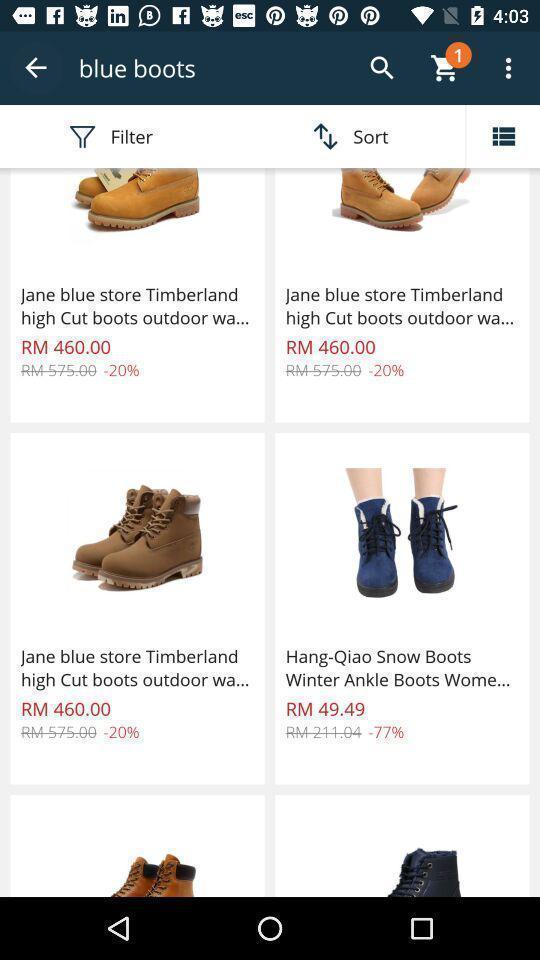Tell me what you see in this picture. Screen showing various brand shoes with prices. 